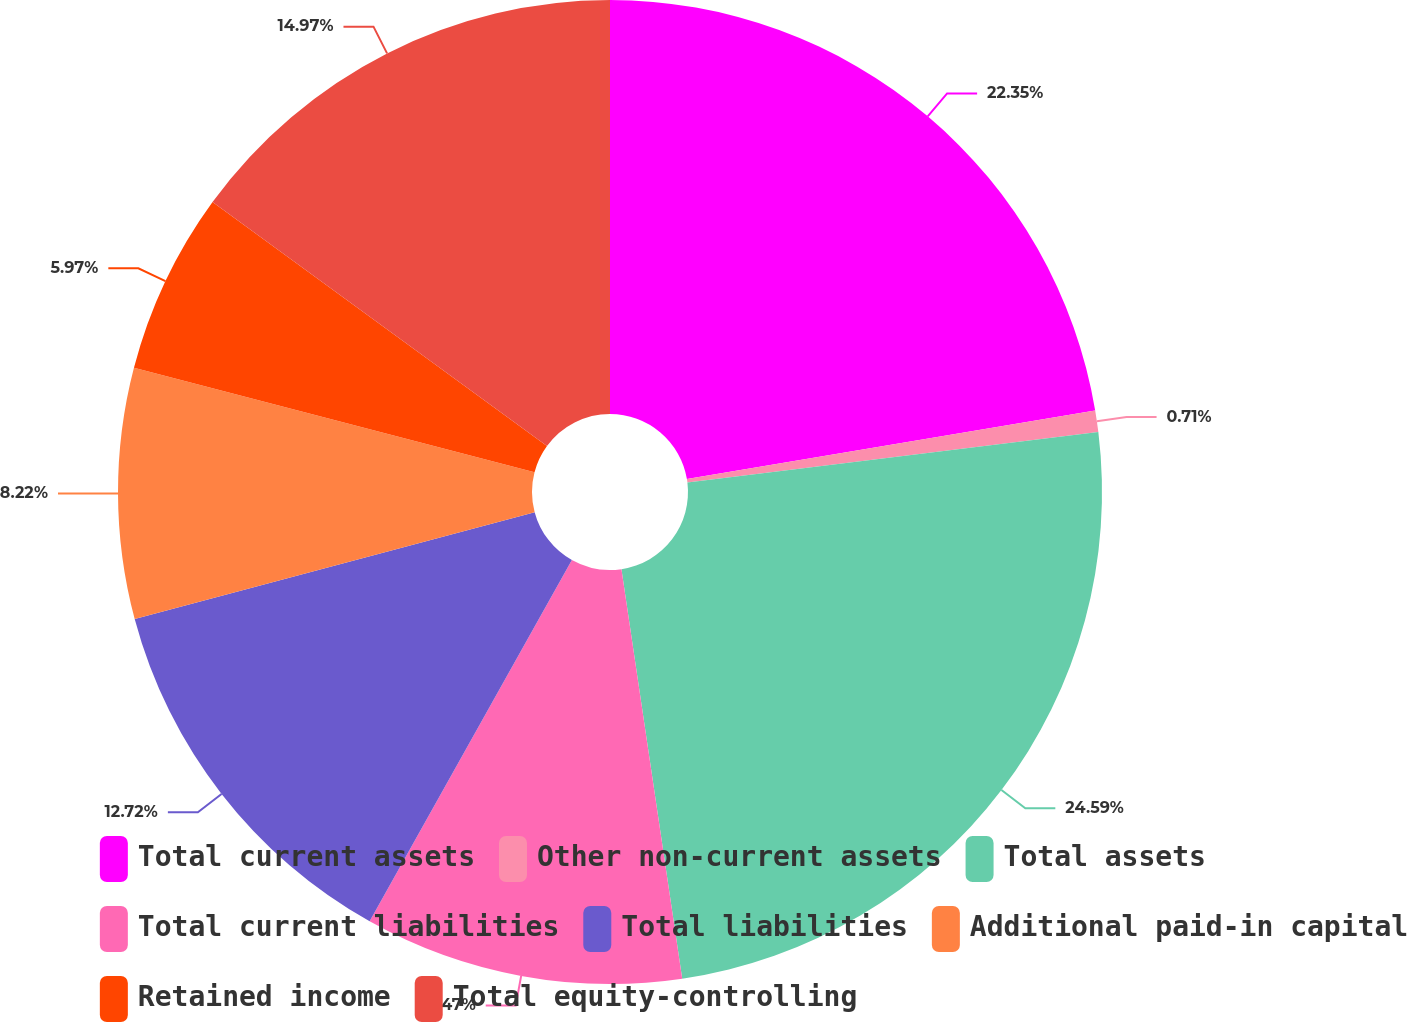Convert chart to OTSL. <chart><loc_0><loc_0><loc_500><loc_500><pie_chart><fcel>Total current assets<fcel>Other non-current assets<fcel>Total assets<fcel>Total current liabilities<fcel>Total liabilities<fcel>Additional paid-in capital<fcel>Retained income<fcel>Total equity-controlling<nl><fcel>22.35%<fcel>0.71%<fcel>24.6%<fcel>10.47%<fcel>12.72%<fcel>8.22%<fcel>5.97%<fcel>14.97%<nl></chart> 